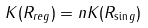<formula> <loc_0><loc_0><loc_500><loc_500>K ( R _ { r e g } ) = n K ( R _ { \sin g } )</formula> 